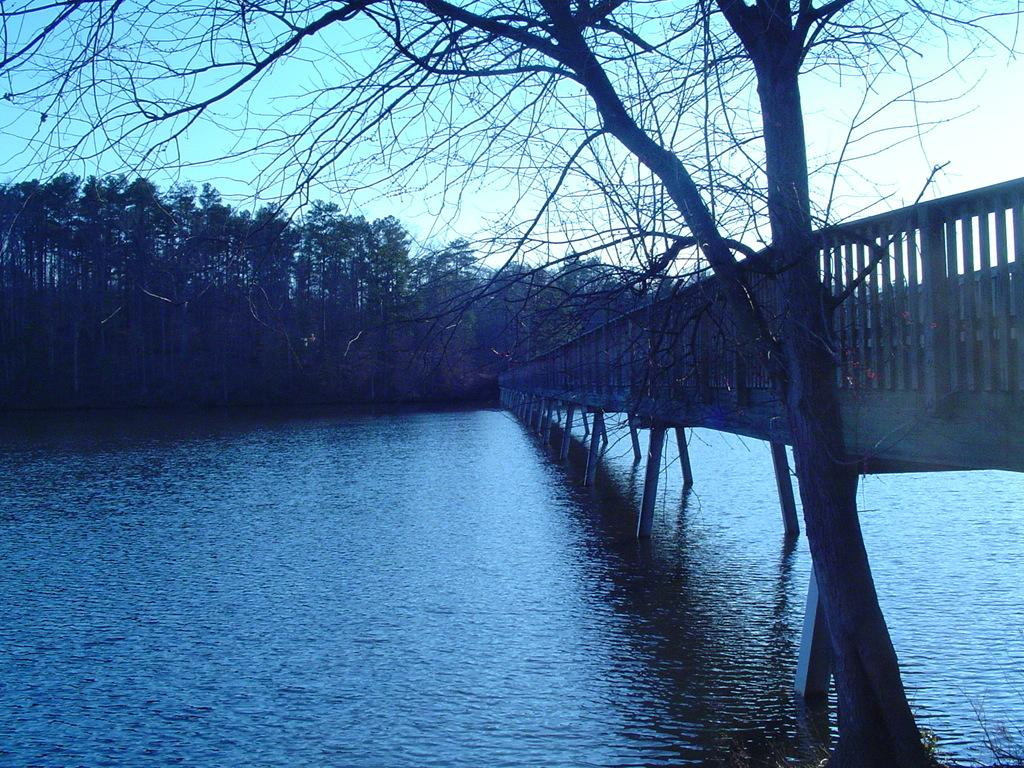What type of natural elements can be seen in the image? There are trees and water in the image. What man-made structure is present in the image? There is a bridge in the image. What can be seen in the background of the image? The sky is visible in the background of the image. Where is the giraffe located in the image? There is no giraffe present in the image. What level of expertise is required to begin using the bridge in the image? The image does not provide information about the level of expertise required to use the bridge, as it is a static image and not a real-life scenario. 